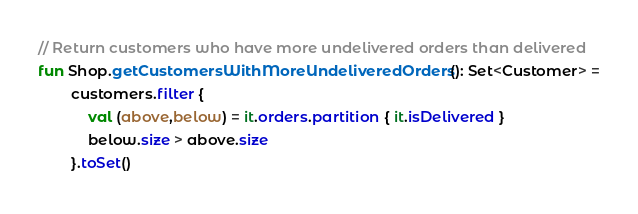Convert code to text. <code><loc_0><loc_0><loc_500><loc_500><_Kotlin_>// Return customers who have more undelivered orders than delivered
fun Shop.getCustomersWithMoreUndeliveredOrders(): Set<Customer> =
        customers.filter {
            val (above,below) = it.orders.partition { it.isDelivered }
            below.size > above.size
        }.toSet()
</code> 